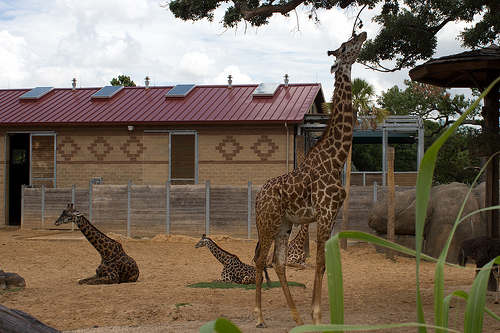Please provide the bounding box coordinate of the region this sentence describes: solar panels on top of giraffe building. The coordinates for the bounding box around the solar panels on top of the building with a giraffe design are [0.04, 0.33, 0.59, 0.41]. 